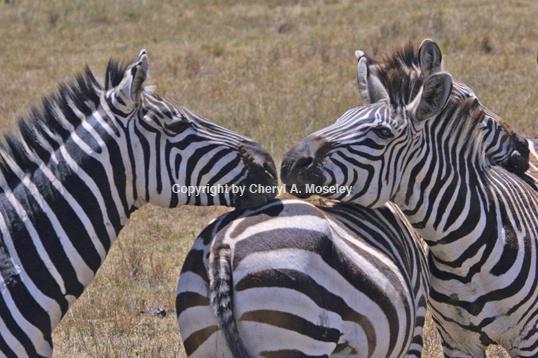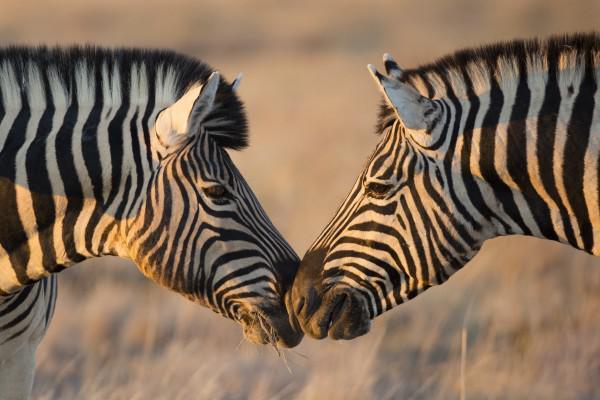The first image is the image on the left, the second image is the image on the right. For the images displayed, is the sentence "The left and right image contains the same number of zebras." factually correct? Answer yes or no. No. The first image is the image on the left, the second image is the image on the right. Evaluate the accuracy of this statement regarding the images: "The right image contains two zebras with their noses touching, and the left image contains three zebras, with two facing each other over the body of the one in the middle.". Is it true? Answer yes or no. Yes. 